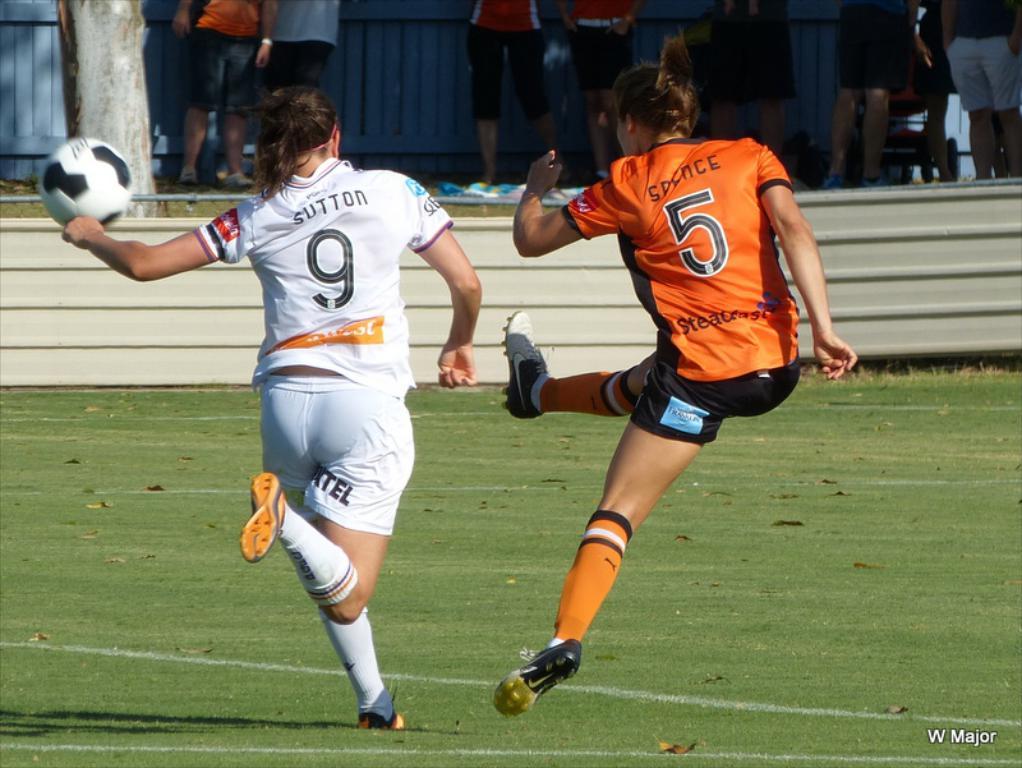What number is the woman with the orange shirt?
Provide a succinct answer. 5. What number is on the back of the white shirt?
Your answer should be very brief. 9. 